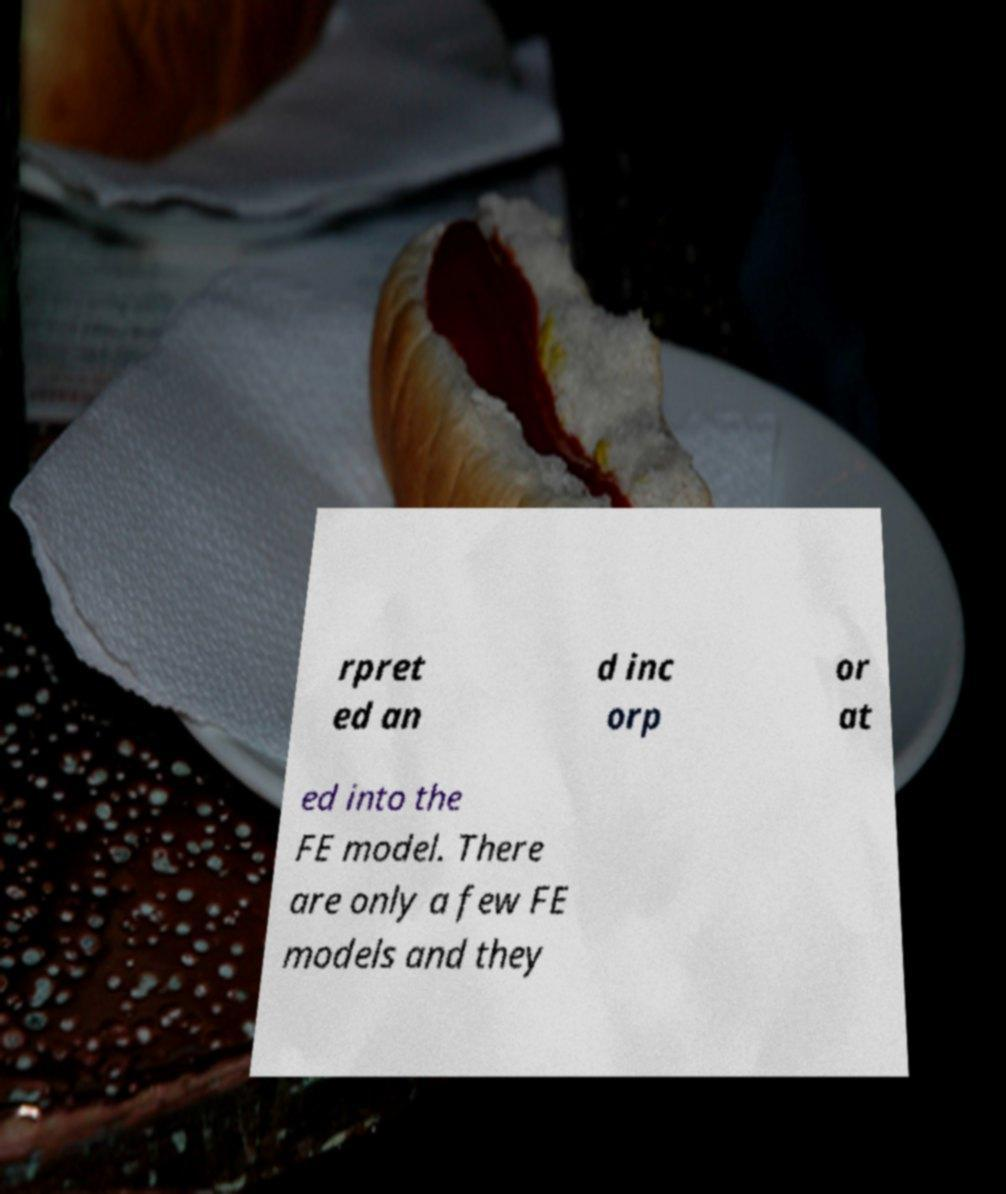There's text embedded in this image that I need extracted. Can you transcribe it verbatim? rpret ed an d inc orp or at ed into the FE model. There are only a few FE models and they 